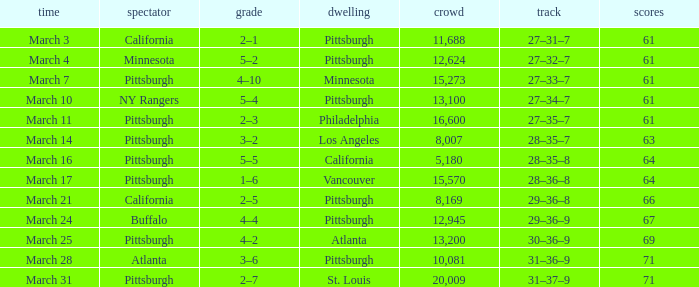What is the Score of the Pittsburgh Home game on March 3 with 61 Points? 2–1. 